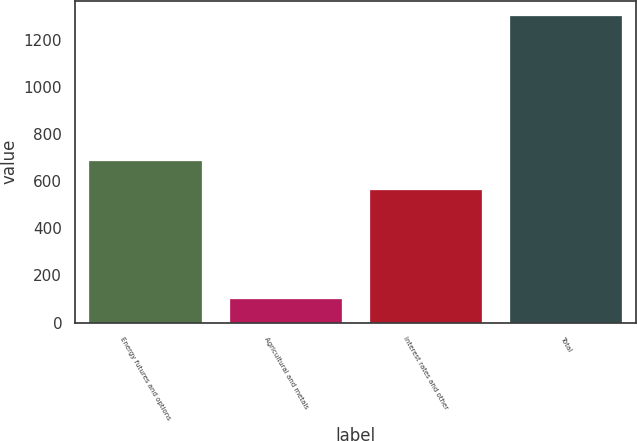Convert chart. <chart><loc_0><loc_0><loc_500><loc_500><bar_chart><fcel>Energy futures and options<fcel>Agricultural and metals<fcel>Interest rates and other<fcel>Total<nl><fcel>683.9<fcel>101<fcel>564<fcel>1300<nl></chart> 